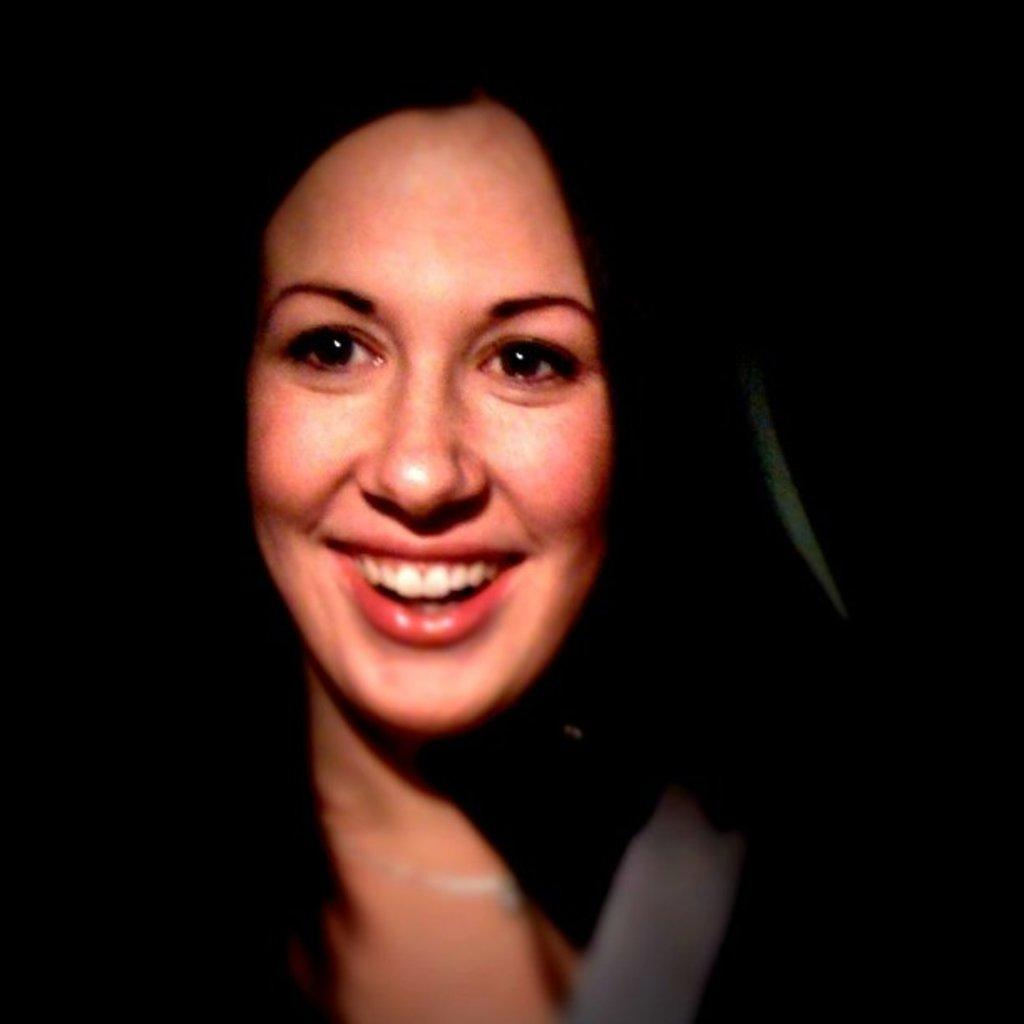Who is present in the image? There is a woman in the image. What is the visual quality of the image's edges? The edges of the image are blurred. How would you describe the background of the image? The background of the image is dark. How much wealth does the bear in the image possess? There is no bear present in the image, so it is not possible to determine its wealth. 